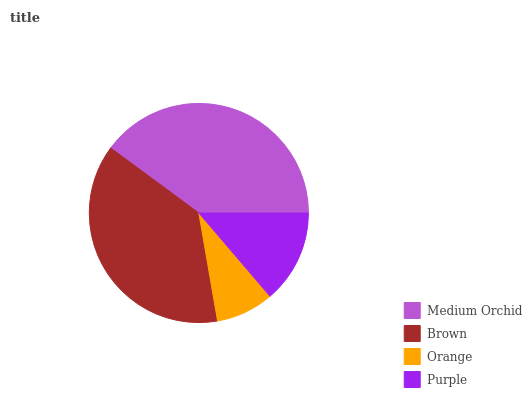Is Orange the minimum?
Answer yes or no. Yes. Is Medium Orchid the maximum?
Answer yes or no. Yes. Is Brown the minimum?
Answer yes or no. No. Is Brown the maximum?
Answer yes or no. No. Is Medium Orchid greater than Brown?
Answer yes or no. Yes. Is Brown less than Medium Orchid?
Answer yes or no. Yes. Is Brown greater than Medium Orchid?
Answer yes or no. No. Is Medium Orchid less than Brown?
Answer yes or no. No. Is Brown the high median?
Answer yes or no. Yes. Is Purple the low median?
Answer yes or no. Yes. Is Medium Orchid the high median?
Answer yes or no. No. Is Orange the low median?
Answer yes or no. No. 